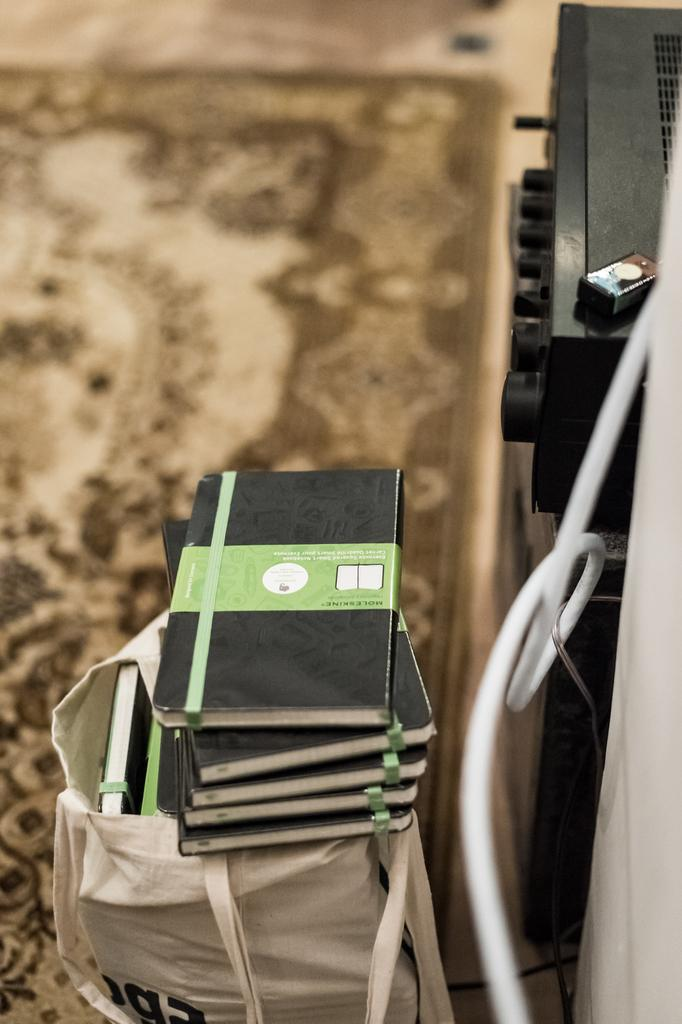What objects can be seen in the image? There are books, electronic devices, and a white wire in the image. What is the color of the books? The books are black in color. Where are the books placed? The books are on a white bag. What is present at the bottom of the image? There is a floor mat at the bottom of the image. Can you tell me how many kittens are sitting on the doctor's throat in the image? There are no kittens or doctors present in the image. The image features books, electronic devices, and a white wire, with no mention of kittens or doctors. 